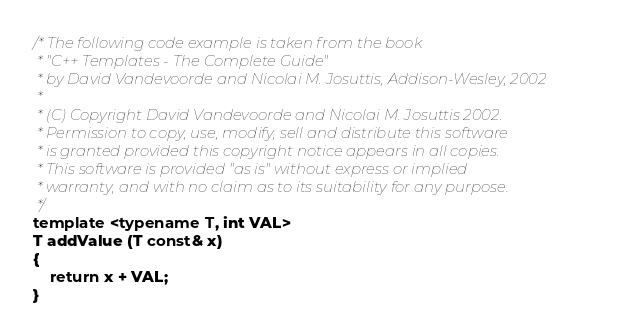Convert code to text. <code><loc_0><loc_0><loc_500><loc_500><_C++_>/* The following code example is taken from the book
 * "C++ Templates - The Complete Guide"
 * by David Vandevoorde and Nicolai M. Josuttis, Addison-Wesley, 2002
 *
 * (C) Copyright David Vandevoorde and Nicolai M. Josuttis 2002.
 * Permission to copy, use, modify, sell and distribute this software
 * is granted provided this copyright notice appears in all copies.
 * This software is provided "as is" without express or implied
 * warranty, and with no claim as to its suitability for any purpose.
 */
template <typename T, int VAL>
T addValue (T const& x)
{
    return x + VAL;
}
</code> 